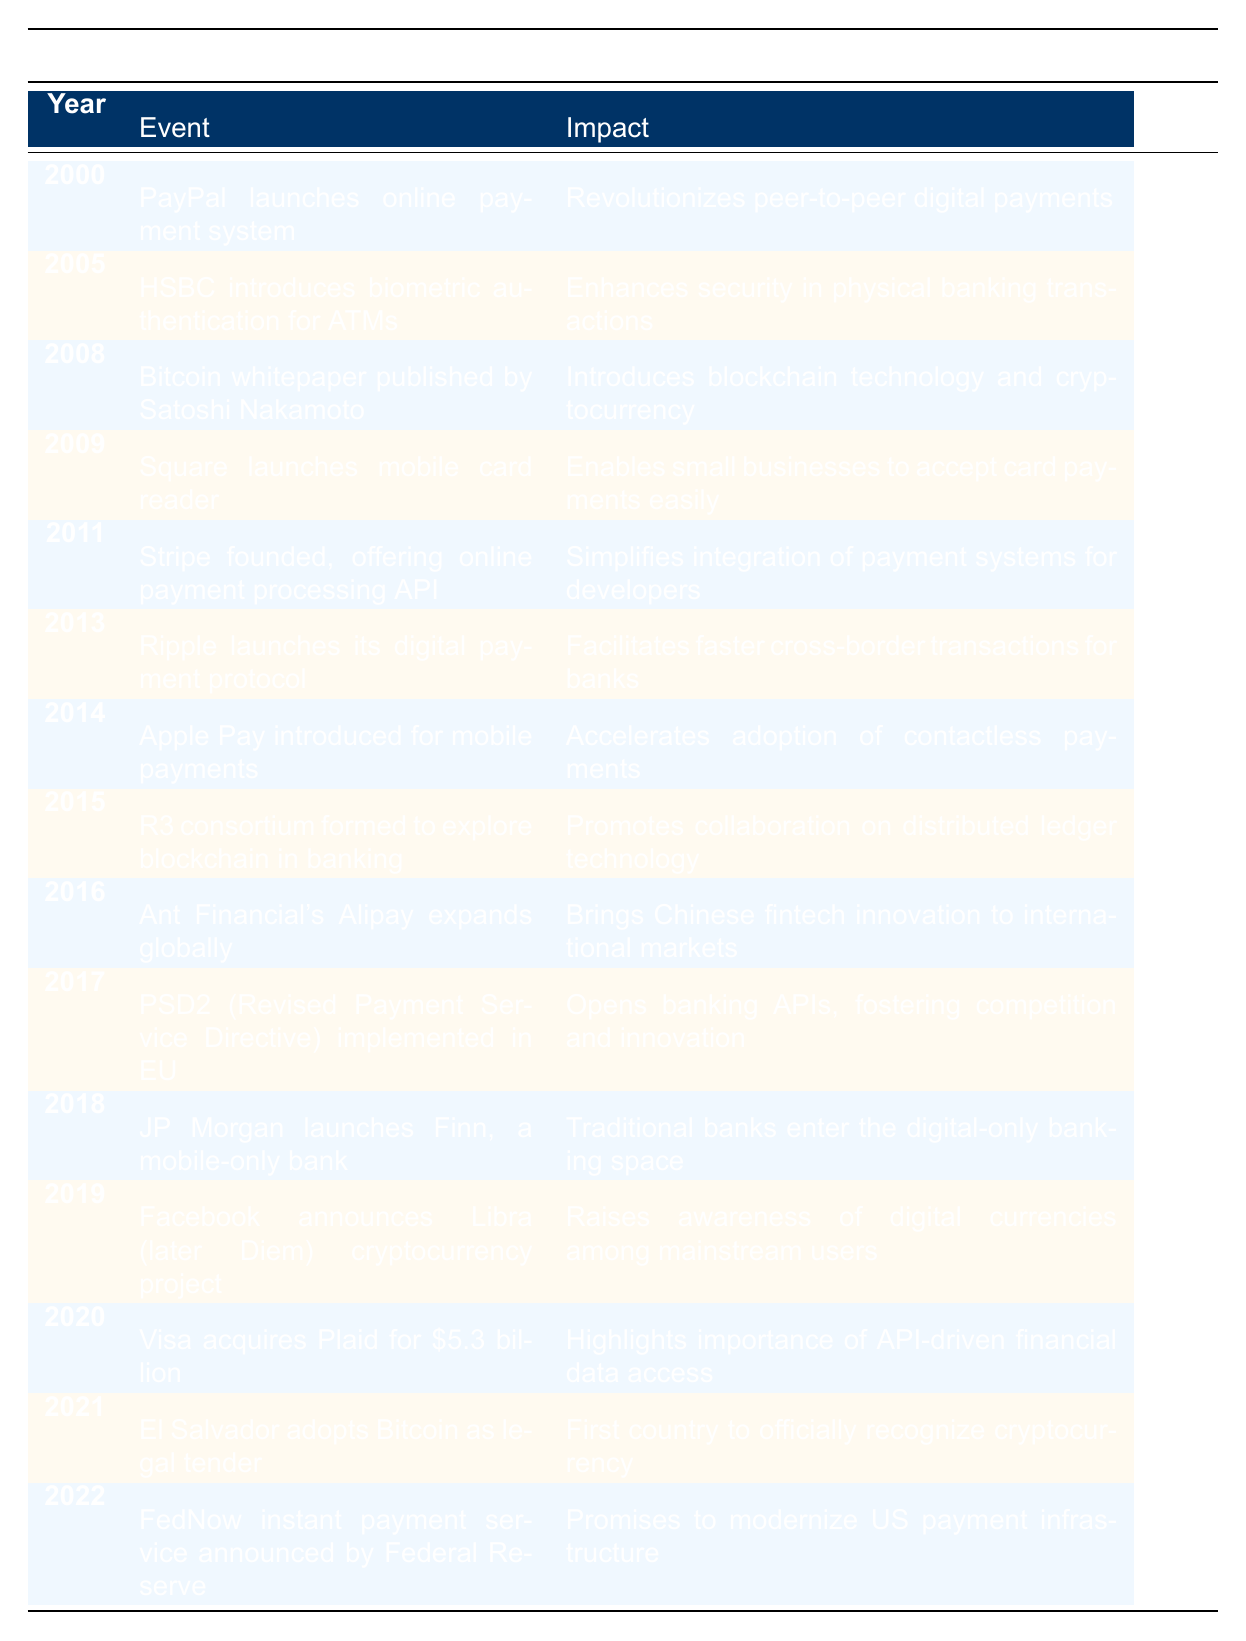What event marked the introduction of blockchain technology in the banking sector? The table indicates that the publication of the Bitcoin whitepaper by Satoshi Nakamoto in 2008 introduced blockchain technology and cryptocurrency, making it a key event.
Answer: Bitcoin whitepaper published by Satoshi Nakamoto Which fintech event occurred in 2011? Referring to the table, the event that took place in 2011 was the founding of Stripe, which offers an online payment processing API.
Answer: Stripe founded, offering online payment processing API How many years apart were the launches of Apple Pay and Visa's acquisition of Plaid? From the table, Apple Pay was introduced in 2014 and Visa acquired Plaid in 2020. The difference is 2020 - 2014 = 6 years.
Answer: 6 years Did Facebook announce a cryptocurrency project before or after 2018? By reviewing the timeline, Facebook announced the Libra (later Diem) cryptocurrency project in 2019, which is after 2018.
Answer: After What significant development in EU banking regulation occurred in 2017? Looking at the table, the implementation of PSD2 (Revised Payment Service Directive) took place in 2017, which is significant for opening banking APIs and fostering competition.
Answer: PSD2 implemented in EU What was the first country to adopt Bitcoin as legal tender? The table specifies that El Salvador adopted Bitcoin as legal tender in 2021, marking it as the first country to do so.
Answer: El Salvador Which two events relate to the enhancement of payment security? According to the table, HSBC introduced biometric authentication for ATMs in 2005, and in 2015, the R3 consortium was formed to explore blockchain technology, promoting security and collaboration in banking.
Answer: HSBC introduces biometric authentication and R3 formed How many fintech innovations were introduced between 2014 and 2019? Counting the events in the table from 2014 (Apple Pay) to 2019 (Facebook announces Libra), we see five entries: Apple Pay (2014), R3 (2015), Ant Financial's Alipay (2016), PSD2 (2017), and Facebook (2019). Thus, there are 5 innovations during this period.
Answer: 5 innovations 